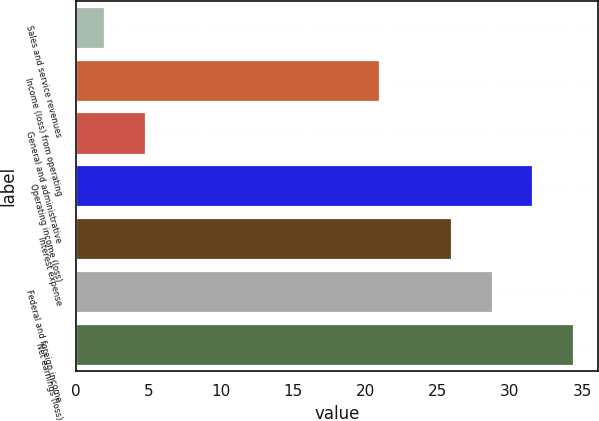Convert chart. <chart><loc_0><loc_0><loc_500><loc_500><bar_chart><fcel>Sales and service revenues<fcel>Income (loss) from operating<fcel>General and administrative<fcel>Operating income (loss)<fcel>Interest expense<fcel>Federal and foreign income<fcel>Net earnings (loss)<nl><fcel>2<fcel>21<fcel>4.8<fcel>31.6<fcel>26<fcel>28.8<fcel>34.4<nl></chart> 